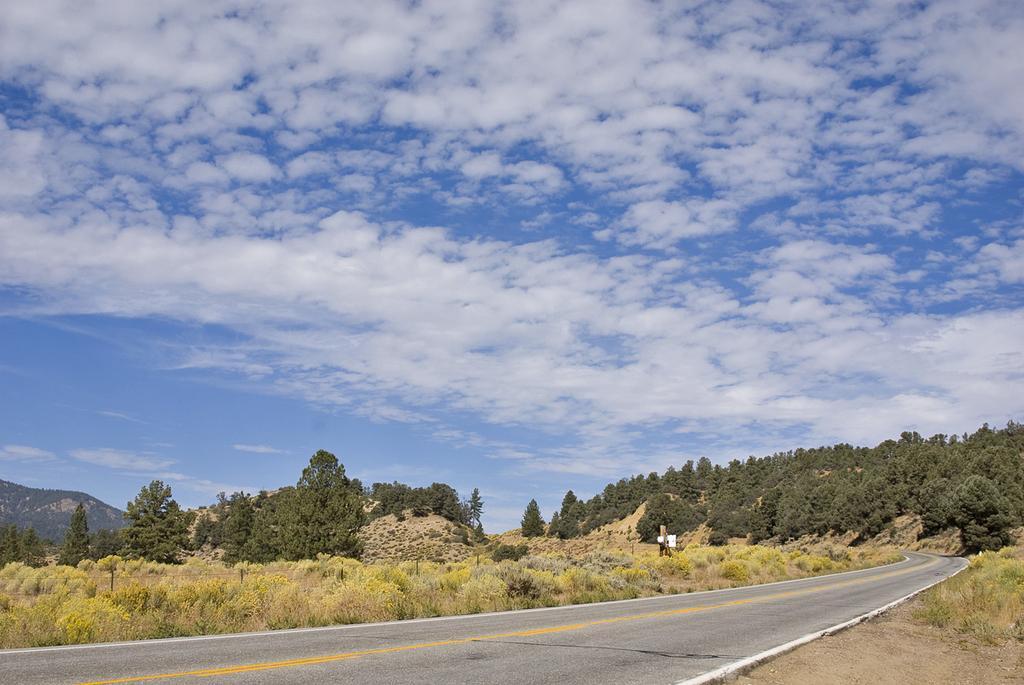How would you summarize this image in a sentence or two? On the left side, there is a road. On both sides of this road, there are plants. In the background, there are trees, mountains and there are clouds in the sky. 